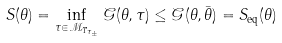<formula> <loc_0><loc_0><loc_500><loc_500>S ( \theta ) = \inf _ { \tau \in \mathcal { M } _ { T _ { \tau _ { \pm } } } } \mathcal { G } ( \theta , \tau ) \leq \mathcal { G } ( \theta , \bar { \theta } ) = S _ { \text {eq} } ( \theta )</formula> 